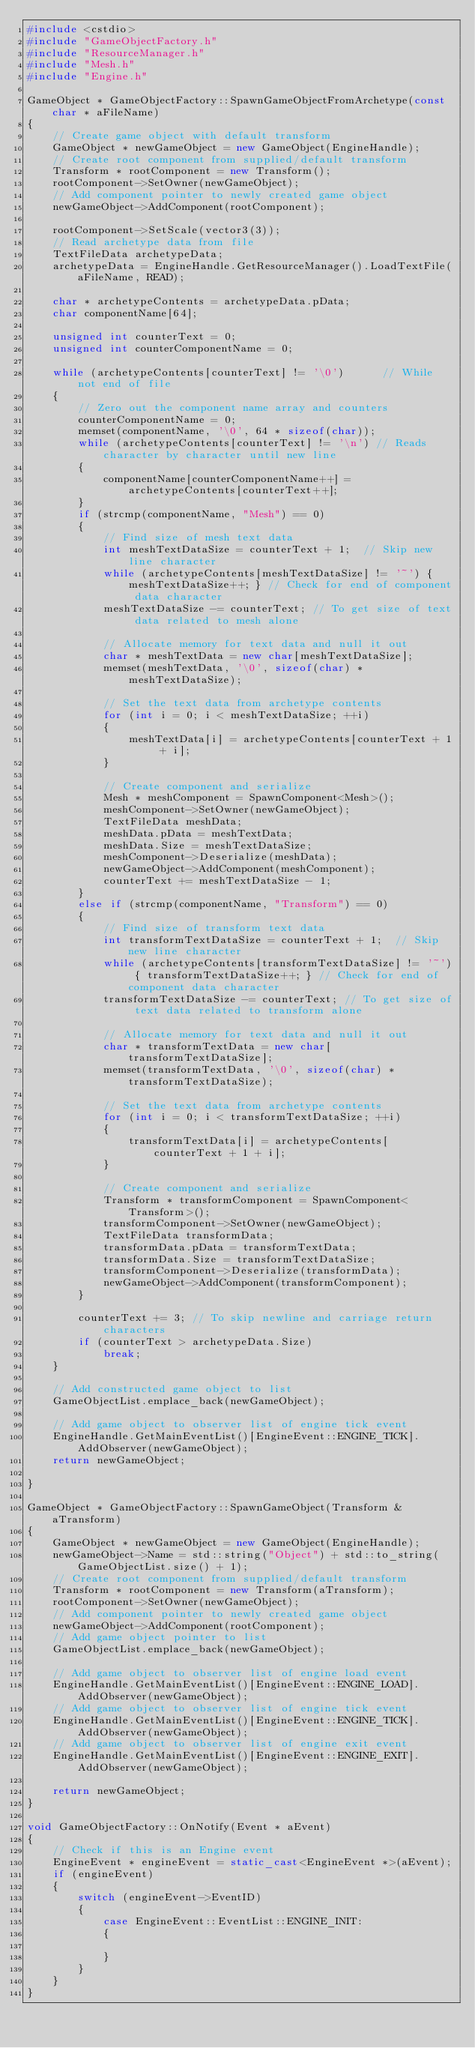Convert code to text. <code><loc_0><loc_0><loc_500><loc_500><_C++_>#include <cstdio>
#include "GameObjectFactory.h"
#include "ResourceManager.h"
#include "Mesh.h"
#include "Engine.h"

GameObject * GameObjectFactory::SpawnGameObjectFromArchetype(const char * aFileName)
{
	// Create game object with default transform
	GameObject * newGameObject = new GameObject(EngineHandle);
	// Create root component from supplied/default transform
	Transform * rootComponent = new Transform();
	rootComponent->SetOwner(newGameObject);
	// Add component pointer to newly created game object
	newGameObject->AddComponent(rootComponent);

	rootComponent->SetScale(vector3(3));
	// Read archetype data from file
	TextFileData archetypeData;
	archetypeData = EngineHandle.GetResourceManager().LoadTextFile(aFileName, READ);

	char * archetypeContents = archetypeData.pData;
	char componentName[64];

	unsigned int counterText = 0;
	unsigned int counterComponentName = 0;
	
	while (archetypeContents[counterText] != '\0')		// While not end of file
	{
		// Zero out the component name array and counters
		counterComponentName = 0;
		memset(componentName, '\0', 64 * sizeof(char));
		while (archetypeContents[counterText] != '\n') // Reads character by character until new line
		{
			componentName[counterComponentName++] = archetypeContents[counterText++];
		}
		if (strcmp(componentName, "Mesh") == 0)	
		{
			// Find size of mesh text data
			int meshTextDataSize = counterText + 1;  // Skip new line character
			while (archetypeContents[meshTextDataSize] != '~') { meshTextDataSize++; } // Check for end of component data character
			meshTextDataSize -= counterText; // To get size of text data related to mesh alone

			// Allocate memory for text data and null it out
			char * meshTextData = new char[meshTextDataSize];
			memset(meshTextData, '\0', sizeof(char) * meshTextDataSize);

			// Set the text data from archetype contents
			for (int i = 0; i < meshTextDataSize; ++i)
			{
				meshTextData[i] = archetypeContents[counterText + 1 + i];
			}
			
			// Create component and serialize
			Mesh * meshComponent = SpawnComponent<Mesh>();
			meshComponent->SetOwner(newGameObject);
			TextFileData meshData;
			meshData.pData = meshTextData;
			meshData.Size = meshTextDataSize;
			meshComponent->Deserialize(meshData);
			newGameObject->AddComponent(meshComponent);
			counterText += meshTextDataSize - 1;
		}
		else if (strcmp(componentName, "Transform") == 0)
		{
			// Find size of transform text data
			int transformTextDataSize = counterText + 1;  // Skip new line character
			while (archetypeContents[transformTextDataSize] != '~') { transformTextDataSize++; } // Check for end of component data character
			transformTextDataSize -= counterText; // To get size of text data related to transform alone

			// Allocate memory for text data and null it out
			char * transformTextData = new char[transformTextDataSize];
			memset(transformTextData, '\0', sizeof(char) * transformTextDataSize);

			// Set the text data from archetype contents
			for (int i = 0; i < transformTextDataSize; ++i)
			{
				transformTextData[i] = archetypeContents[counterText + 1 + i];
			}

			// Create component and serialize
			Transform * transformComponent = SpawnComponent<Transform>();
			transformComponent->SetOwner(newGameObject);
			TextFileData transformData;
			transformData.pData = transformTextData;
			transformData.Size = transformTextDataSize;
			transformComponent->Deserialize(transformData);
			newGameObject->AddComponent(transformComponent);
		}
	
		counterText += 3; // To skip newline and carriage return characters
		if (counterText > archetypeData.Size)
			break;
	}
	
	// Add constructed game object to list
	GameObjectList.emplace_back(newGameObject);
	
	// Add game object to observer list of engine tick event
	EngineHandle.GetMainEventList()[EngineEvent::ENGINE_TICK].AddObserver(newGameObject);
	return newGameObject;

}

GameObject * GameObjectFactory::SpawnGameObject(Transform & aTransform)
{
	GameObject * newGameObject = new GameObject(EngineHandle);
	newGameObject->Name = std::string("Object") + std::to_string(GameObjectList.size() + 1);
	// Create root component from supplied/default transform
	Transform * rootComponent = new Transform(aTransform);
	rootComponent->SetOwner(newGameObject);
	// Add component pointer to newly created game object
	newGameObject->AddComponent(rootComponent);
	// Add game object pointer to list
	GameObjectList.emplace_back(newGameObject);

	// Add game object to observer list of engine load event
	EngineHandle.GetMainEventList()[EngineEvent::ENGINE_LOAD].AddObserver(newGameObject);
	// Add game object to observer list of engine tick event
	EngineHandle.GetMainEventList()[EngineEvent::ENGINE_TICK].AddObserver(newGameObject);
	// Add game object to observer list of engine exit event
	EngineHandle.GetMainEventList()[EngineEvent::ENGINE_EXIT].AddObserver(newGameObject);

	return newGameObject;
}

void GameObjectFactory::OnNotify(Event * aEvent)
{
	// Check if this is an Engine event
	EngineEvent * engineEvent = static_cast<EngineEvent *>(aEvent);
	if (engineEvent)
	{
		switch (engineEvent->EventID)
		{
			case EngineEvent::EventList::ENGINE_INIT:
			{
				
			}
		}
	}
}
</code> 